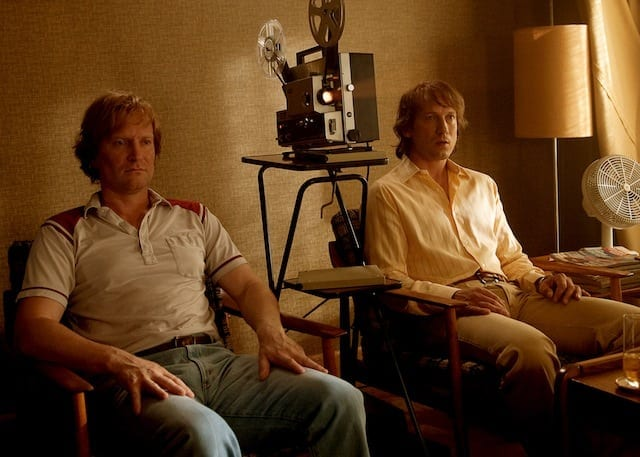What does the setting reveal about the time period of this image? The setting, with its vintage film projector, analog fan, and the overall style of furniture and room decoration, suggests a timeframe that could be in the late 20th century. These elements give the room a retro feel, indicative of a period where such equipment was commonplace in artistic and cinematic environments. 